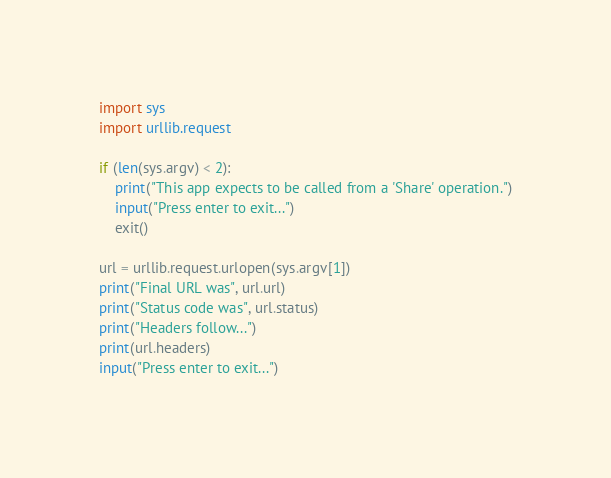Convert code to text. <code><loc_0><loc_0><loc_500><loc_500><_Python_>import sys
import urllib.request

if (len(sys.argv) < 2):
    print("This app expects to be called from a 'Share' operation.")
    input("Press enter to exit...")
    exit()

url = urllib.request.urlopen(sys.argv[1])
print("Final URL was", url.url)
print("Status code was", url.status)
print("Headers follow...")
print(url.headers)
input("Press enter to exit...")
</code> 